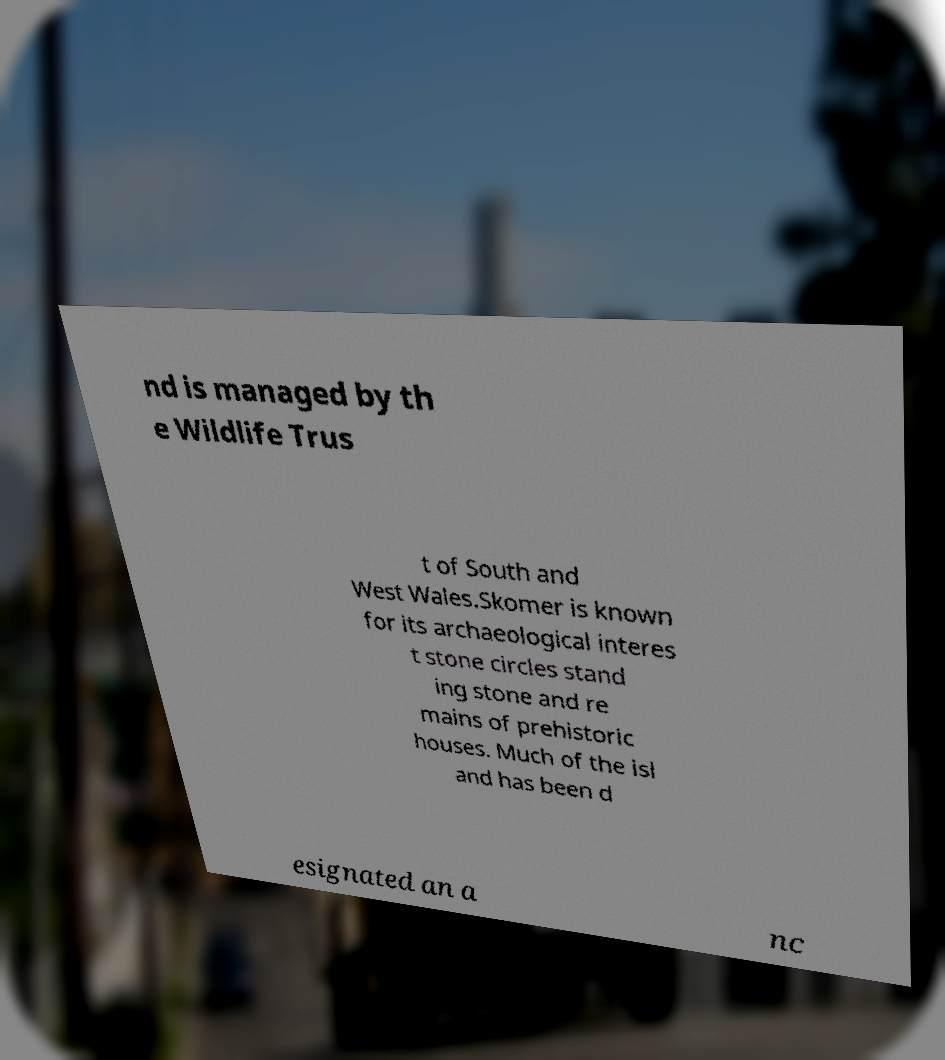There's text embedded in this image that I need extracted. Can you transcribe it verbatim? nd is managed by th e Wildlife Trus t of South and West Wales.Skomer is known for its archaeological interes t stone circles stand ing stone and re mains of prehistoric houses. Much of the isl and has been d esignated an a nc 